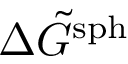Convert formula to latex. <formula><loc_0><loc_0><loc_500><loc_500>\Delta \tilde { G } ^ { s p h }</formula> 